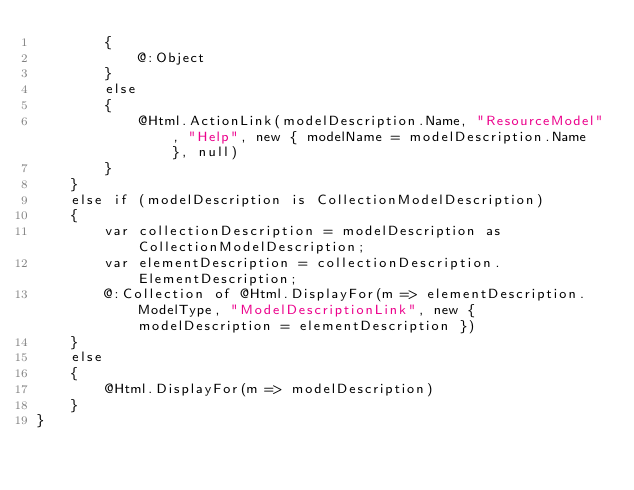<code> <loc_0><loc_0><loc_500><loc_500><_C#_>        {
            @:Object
        }
        else
        {
            @Html.ActionLink(modelDescription.Name, "ResourceModel", "Help", new { modelName = modelDescription.Name }, null)
        }
    }
    else if (modelDescription is CollectionModelDescription)
    {
        var collectionDescription = modelDescription as CollectionModelDescription;
        var elementDescription = collectionDescription.ElementDescription;
        @:Collection of @Html.DisplayFor(m => elementDescription.ModelType, "ModelDescriptionLink", new { modelDescription = elementDescription })
    }
    else
    {
        @Html.DisplayFor(m => modelDescription)
    }
}</code> 